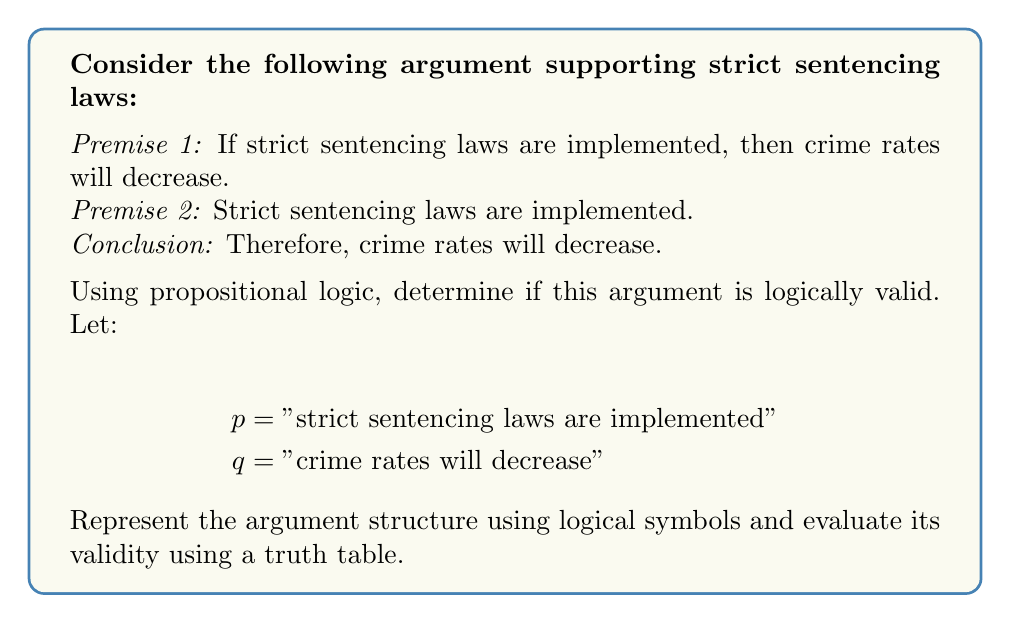Teach me how to tackle this problem. To determine the logical validity of this argument, we need to follow these steps:

1. Represent the argument using logical symbols:
   Premise 1: $p \rightarrow q$
   Premise 2: $p$
   Conclusion: $q$

   The argument structure is: $((p \rightarrow q) \land p) \rightarrow q$

2. Create a truth table for this logical statement:

   $$\begin{array}{|c|c|c|c|c|c|}
   \hline
   p & q & p \rightarrow q & (p \rightarrow q) \land p & ((p \rightarrow q) \land p) \rightarrow q \\
   \hline
   T & T & T & T & T \\
   T & F & F & F & T \\
   F & T & T & F & T \\
   F & F & T & F & T \\
   \hline
   \end{array}$$

3. Analyze the truth table:
   - The last column represents the validity of the argument.
   - If the last column contains all true values (T), the argument is logically valid.
   - In this case, we can see that all values in the last column are indeed T.

4. Interpretation:
   This argument form is known as Modus Ponens, which is a valid form of argument in propositional logic. It states that if we have a conditional statement ($p \rightarrow q$) and the antecedent ($p$) is true, then we can conclude that the consequent ($q$) must also be true.

Therefore, based on the truth table analysis, we can conclude that this argument is logically valid. However, it's important to note that logical validity does not guarantee that the premises or conclusion are actually true in the real world, only that the conclusion follows logically from the premises if they are assumed to be true.
Answer: The argument is logically valid. 